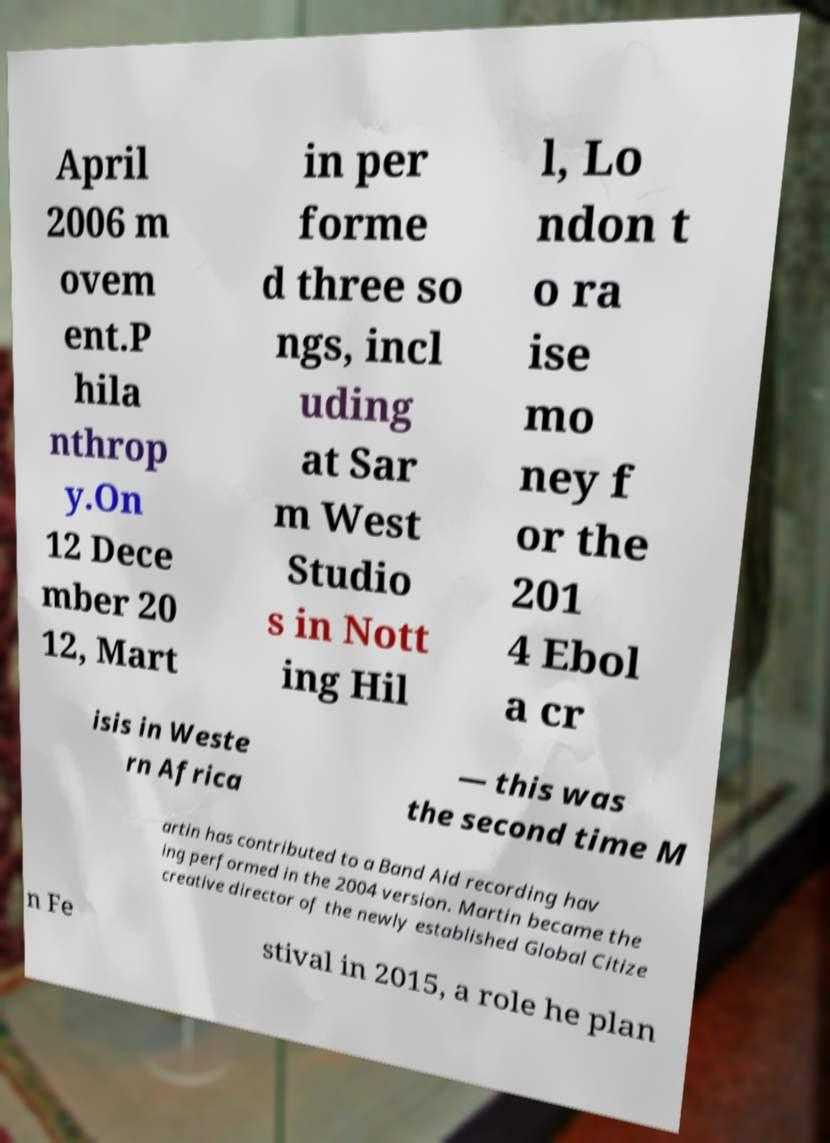Can you accurately transcribe the text from the provided image for me? April 2006 m ovem ent.P hila nthrop y.On 12 Dece mber 20 12, Mart in per forme d three so ngs, incl uding at Sar m West Studio s in Nott ing Hil l, Lo ndon t o ra ise mo ney f or the 201 4 Ebol a cr isis in Weste rn Africa — this was the second time M artin has contributed to a Band Aid recording hav ing performed in the 2004 version. Martin became the creative director of the newly established Global Citize n Fe stival in 2015, a role he plan 